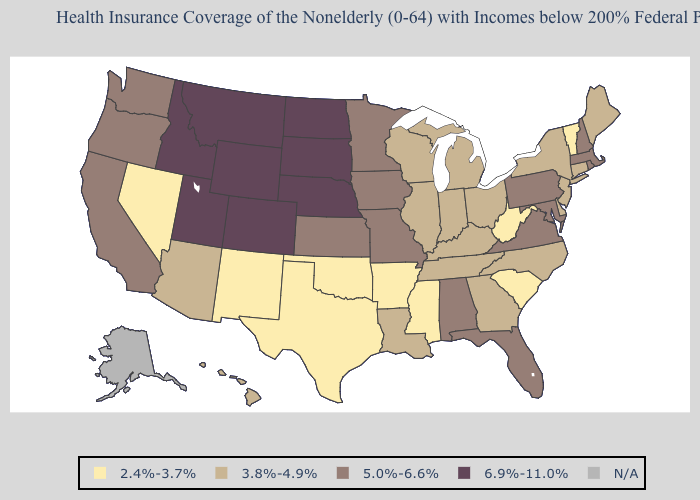Does Louisiana have the highest value in the South?
Concise answer only. No. What is the value of Montana?
Give a very brief answer. 6.9%-11.0%. Which states have the lowest value in the South?
Write a very short answer. Arkansas, Mississippi, Oklahoma, South Carolina, Texas, West Virginia. Name the states that have a value in the range 3.8%-4.9%?
Answer briefly. Arizona, Connecticut, Delaware, Georgia, Hawaii, Illinois, Indiana, Kentucky, Louisiana, Maine, Michigan, New Jersey, New York, North Carolina, Ohio, Tennessee, Wisconsin. Is the legend a continuous bar?
Answer briefly. No. What is the value of Connecticut?
Keep it brief. 3.8%-4.9%. Does Minnesota have the highest value in the USA?
Concise answer only. No. Name the states that have a value in the range 6.9%-11.0%?
Be succinct. Colorado, Idaho, Montana, Nebraska, North Dakota, South Dakota, Utah, Wyoming. Does Montana have the highest value in the USA?
Write a very short answer. Yes. Name the states that have a value in the range 5.0%-6.6%?
Answer briefly. Alabama, California, Florida, Iowa, Kansas, Maryland, Massachusetts, Minnesota, Missouri, New Hampshire, Oregon, Pennsylvania, Rhode Island, Virginia, Washington. Which states hav the highest value in the West?
Keep it brief. Colorado, Idaho, Montana, Utah, Wyoming. How many symbols are there in the legend?
Keep it brief. 5. Which states have the lowest value in the South?
Concise answer only. Arkansas, Mississippi, Oklahoma, South Carolina, Texas, West Virginia. What is the value of New Jersey?
Concise answer only. 3.8%-4.9%. Which states have the lowest value in the USA?
Quick response, please. Arkansas, Mississippi, Nevada, New Mexico, Oklahoma, South Carolina, Texas, Vermont, West Virginia. 